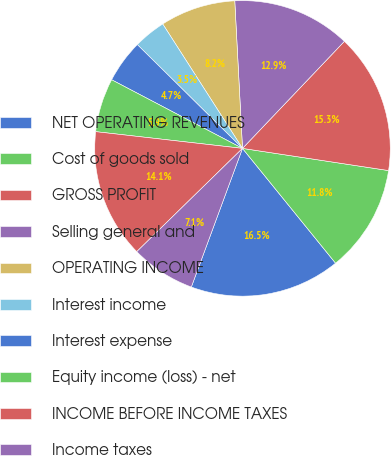<chart> <loc_0><loc_0><loc_500><loc_500><pie_chart><fcel>NET OPERATING REVENUES<fcel>Cost of goods sold<fcel>GROSS PROFIT<fcel>Selling general and<fcel>OPERATING INCOME<fcel>Interest income<fcel>Interest expense<fcel>Equity income (loss) - net<fcel>INCOME BEFORE INCOME TAXES<fcel>Income taxes<nl><fcel>16.47%<fcel>11.76%<fcel>15.29%<fcel>12.94%<fcel>8.24%<fcel>3.53%<fcel>4.71%<fcel>5.88%<fcel>14.12%<fcel>7.06%<nl></chart> 